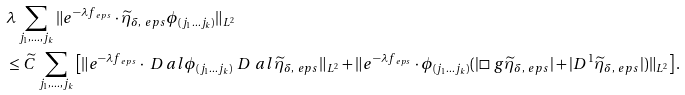<formula> <loc_0><loc_0><loc_500><loc_500>& \lambda \sum _ { j _ { 1 } , \dots , j _ { k } } \| e ^ { - \lambda f _ { \ e p s } } \cdot \widetilde { \eta } _ { \delta , \ e p s } \phi _ { ( j _ { 1 } \dots j _ { k } ) } \| _ { L ^ { 2 } } \\ & \leq \widetilde { C } \sum _ { j _ { 1 } , \dots , j _ { k } } \left [ \| e ^ { - \lambda f _ { \ e p s } } \cdot \ D _ { \ } a l \phi _ { ( j _ { 1 } \dots j _ { k } ) } \ D ^ { \ } a l \widetilde { \eta } _ { \delta , \ e p s } \| _ { L ^ { 2 } } + \| e ^ { - \lambda f _ { \ e p s } } \cdot \phi _ { ( j _ { 1 } \dots j _ { k } ) } ( | \square _ { \ } g \widetilde { \eta } _ { \delta , \ e p s } | + | D ^ { 1 } \widetilde { \eta } _ { \delta , \ e p s } | ) \| _ { L ^ { 2 } } \right ] .</formula> 